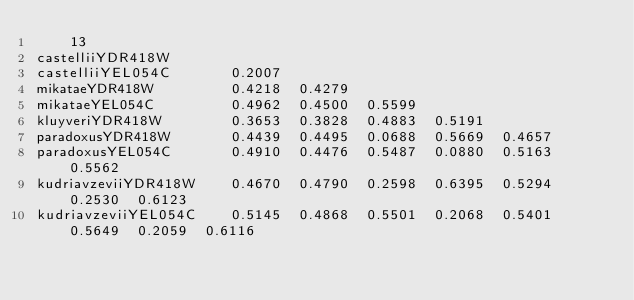<code> <loc_0><loc_0><loc_500><loc_500><_Perl_>    13
castelliiYDR418W     
castelliiYEL054C       0.2007
mikataeYDR418W         0.4218  0.4279
mikataeYEL054C         0.4962  0.4500  0.5599
kluyveriYDR418W        0.3653  0.3828  0.4883  0.5191
paradoxusYDR418W       0.4439  0.4495  0.0688  0.5669  0.4657
paradoxusYEL054C       0.4910  0.4476  0.5487  0.0880  0.5163  0.5562
kudriavzeviiYDR418W    0.4670  0.4790  0.2598  0.6395  0.5294  0.2530  0.6123
kudriavzeviiYEL054C    0.5145  0.4868  0.5501  0.2068  0.5401  0.5649  0.2059  0.6116</code> 